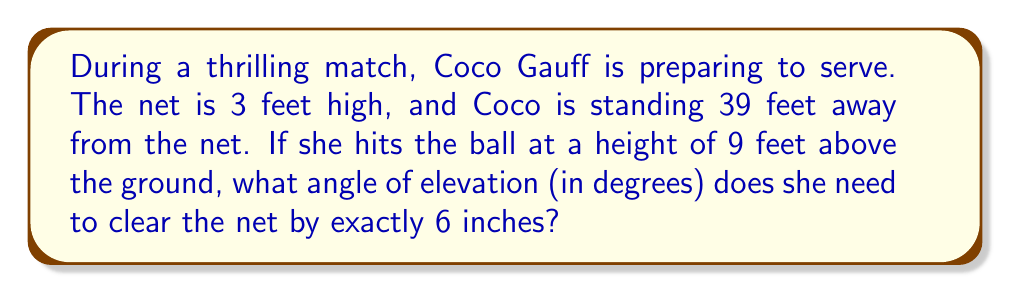Could you help me with this problem? Let's approach this step-by-step:

1) First, we need to visualize the problem:

[asy]
import geometry;

pair A = (0,0), B = (39,3), C = (0,9), D = (39,3.5);
draw(A--B--C--A);
draw(C--D,dashed);
label("Ground",A,SW);
label("Net",B,E);
label("Coco",C,W);
label("Ball path",D,NE);
label("39 ft",A--B,S);
label("9 ft",A--C,W);
label("3 ft",B--(39,0),E);
label("6 in",B--D,E);
label("$\theta$",(0,9),NE);
[/asy]

2) We can treat this as a right triangle problem. The angle we're looking for is the angle of elevation, $\theta$.

3) We know:
   - The horizontal distance to the net is 39 feet
   - The height difference between the ball at impact and the desired clearance point is: 
     $9 - (3 + 0.5) = 5.5$ feet (remember, 6 inches = 0.5 feet)

4) We can use the tangent function to find the angle:

   $$\tan(\theta) = \frac{\text{opposite}}{\text{adjacent}} = \frac{5.5}{39}$$

5) To find $\theta$, we need to use the inverse tangent (arctan) function:

   $$\theta = \arctan(\frac{5.5}{39})$$

6) Using a calculator:

   $$\theta = \arctan(0.1410) \approx 8.0305^\circ$$

7) Rounding to the nearest tenth of a degree:

   $$\theta \approx 8.0^\circ$$
Answer: $8.0^\circ$ 